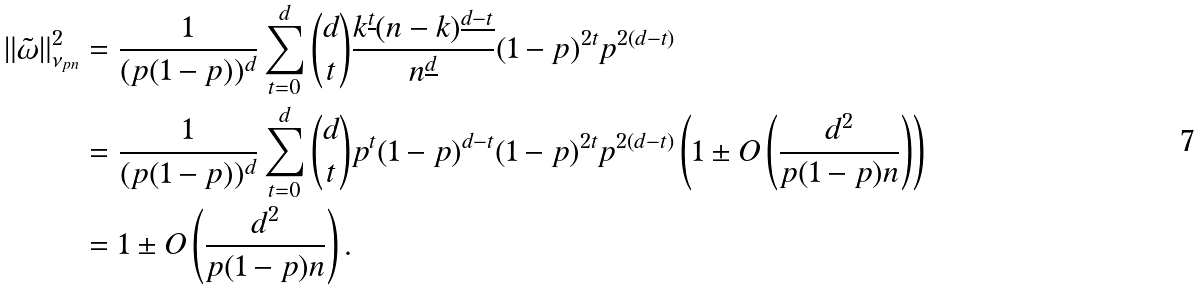Convert formula to latex. <formula><loc_0><loc_0><loc_500><loc_500>\| \tilde { \omega } \| _ { \nu _ { p n } } ^ { 2 } & = \frac { 1 } { ( p ( 1 - p ) ) ^ { d } } \sum _ { t = 0 } ^ { d } \binom { d } { t } \frac { k ^ { \underline { t } } ( n - k ) ^ { \underline { d - t } } } { n ^ { \underline { d } } } ( 1 - p ) ^ { 2 t } p ^ { 2 ( d - t ) } \\ & = \frac { 1 } { ( p ( 1 - p ) ) ^ { d } } \sum _ { t = 0 } ^ { d } \binom { d } { t } p ^ { t } ( 1 - p ) ^ { d - t } ( 1 - p ) ^ { 2 t } p ^ { 2 ( d - t ) } \left ( 1 \pm O \left ( \frac { d ^ { 2 } } { p ( 1 - p ) n } \right ) \right ) \\ & = 1 \pm O \left ( \frac { d ^ { 2 } } { p ( 1 - p ) n } \right ) .</formula> 